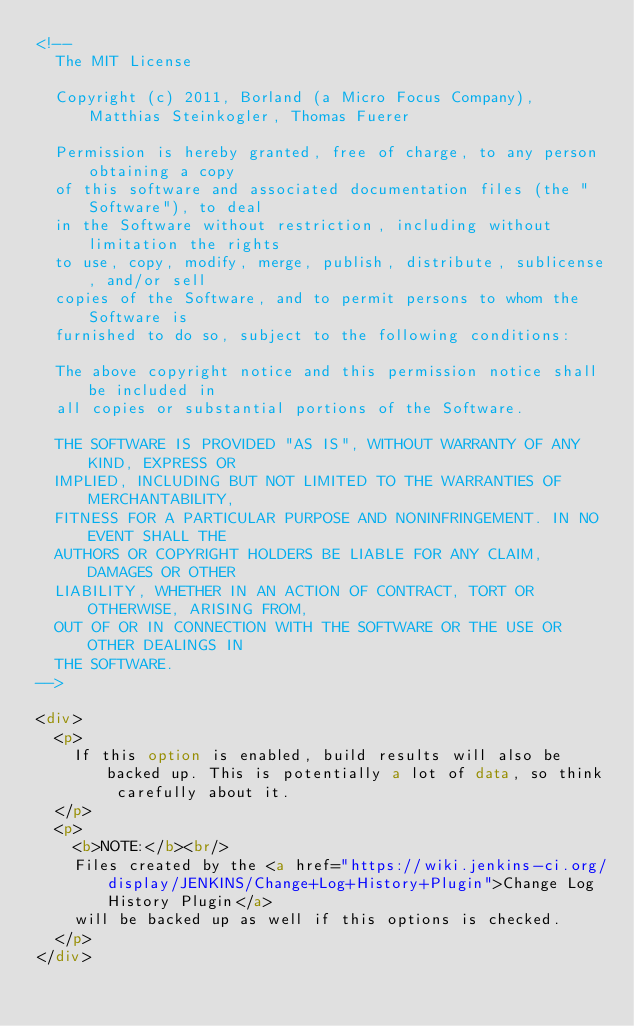Convert code to text. <code><loc_0><loc_0><loc_500><loc_500><_HTML_><!--
  The MIT License
 
  Copyright (c) 2011, Borland (a Micro Focus Company), Matthias Steinkogler, Thomas Fuerer
 
  Permission is hereby granted, free of charge, to any person obtaining a copy
  of this software and associated documentation files (the "Software"), to deal
  in the Software without restriction, including without limitation the rights
  to use, copy, modify, merge, publish, distribute, sublicense, and/or sell
  copies of the Software, and to permit persons to whom the Software is
  furnished to do so, subject to the following conditions:
 
  The above copyright notice and this permission notice shall be included in
  all copies or substantial portions of the Software.
 
  THE SOFTWARE IS PROVIDED "AS IS", WITHOUT WARRANTY OF ANY KIND, EXPRESS OR
  IMPLIED, INCLUDING BUT NOT LIMITED TO THE WARRANTIES OF MERCHANTABILITY,
  FITNESS FOR A PARTICULAR PURPOSE AND NONINFRINGEMENT. IN NO EVENT SHALL THE
  AUTHORS OR COPYRIGHT HOLDERS BE LIABLE FOR ANY CLAIM, DAMAGES OR OTHER
  LIABILITY, WHETHER IN AN ACTION OF CONTRACT, TORT OR OTHERWISE, ARISING FROM,
  OUT OF OR IN CONNECTION WITH THE SOFTWARE OR THE USE OR OTHER DEALINGS IN
  THE SOFTWARE.
-->

<div>
  <p>
    If this option is enabled, build results will also be backed up. This is potentially a lot of data, so think carefully about it.
  </p>
  <p>
    <b>NOTE:</b><br/>
    Files created by the <a href="https://wiki.jenkins-ci.org/display/JENKINS/Change+Log+History+Plugin">Change Log History Plugin</a> 
    will be backed up as well if this options is checked.
  </p>
</div>
</code> 